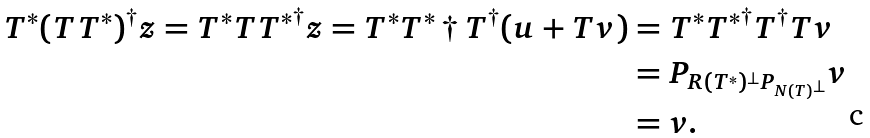<formula> <loc_0><loc_0><loc_500><loc_500>T ^ { * } ( T T ^ { * } ) ^ { \dagger } z = T ^ { * } T { T ^ { * } } ^ { \dagger } z = T ^ { * } { T ^ { * } } \dagger T ^ { \dagger } ( u + T v ) & = T ^ { * } { T ^ { * } } ^ { \dagger } T ^ { \dagger } T v \\ & = P _ { R ( T ^ { * } ) ^ { \bot } P _ { N ( T ) ^ { \bot } } } v \\ & = v .</formula> 